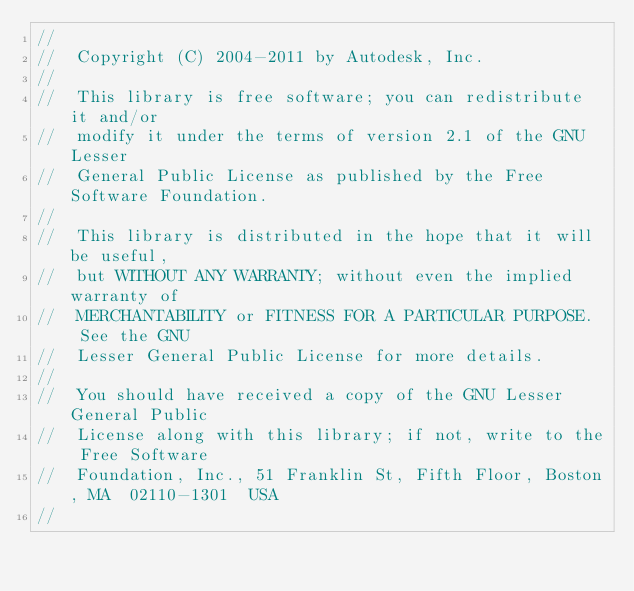<code> <loc_0><loc_0><loc_500><loc_500><_C++_>//
//  Copyright (C) 2004-2011 by Autodesk, Inc.
//
//  This library is free software; you can redistribute it and/or
//  modify it under the terms of version 2.1 of the GNU Lesser
//  General Public License as published by the Free Software Foundation.
//
//  This library is distributed in the hope that it will be useful,
//  but WITHOUT ANY WARRANTY; without even the implied warranty of
//  MERCHANTABILITY or FITNESS FOR A PARTICULAR PURPOSE.  See the GNU
//  Lesser General Public License for more details.
//
//  You should have received a copy of the GNU Lesser General Public
//  License along with this library; if not, write to the Free Software
//  Foundation, Inc., 51 Franklin St, Fifth Floor, Boston, MA  02110-1301  USA
//
</code> 